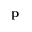<formula> <loc_0><loc_0><loc_500><loc_500>p</formula> 